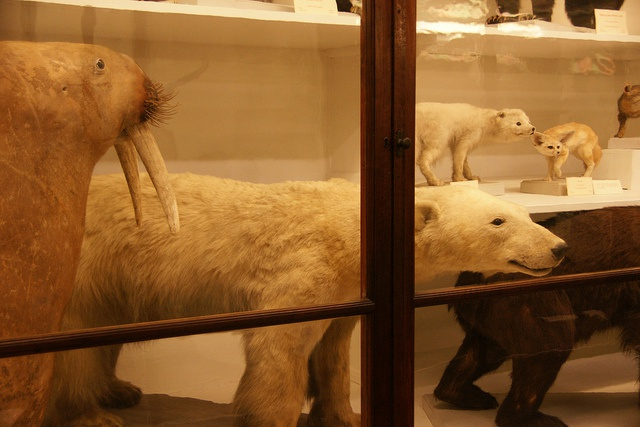Describe the objects in this image and their specific colors. I can see bear in maroon, brown, and orange tones and bear in maroon, black, and brown tones in this image. 